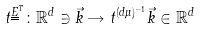<formula> <loc_0><loc_0><loc_500><loc_500>t ^ { \underline { \underline { E } } ^ { T } } \colon \mathbb { R } ^ { d } \ni \vec { k } \rightarrow t ^ { ( d \mu ) ^ { - 1 } } \vec { k } \in \mathbb { R } ^ { d }</formula> 